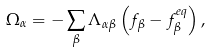<formula> <loc_0><loc_0><loc_500><loc_500>\Omega _ { \alpha } = - \sum _ { \beta } \Lambda _ { \alpha \beta } \left ( f _ { \beta } - f _ { \beta } ^ { e q } \right ) ,</formula> 